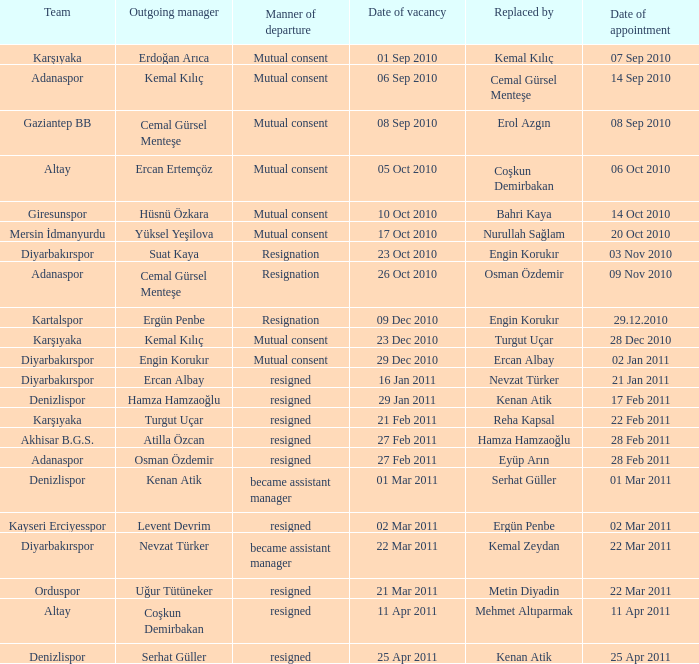When was the date of vacancy for the manager of Kartalspor?  09 Dec 2010. 